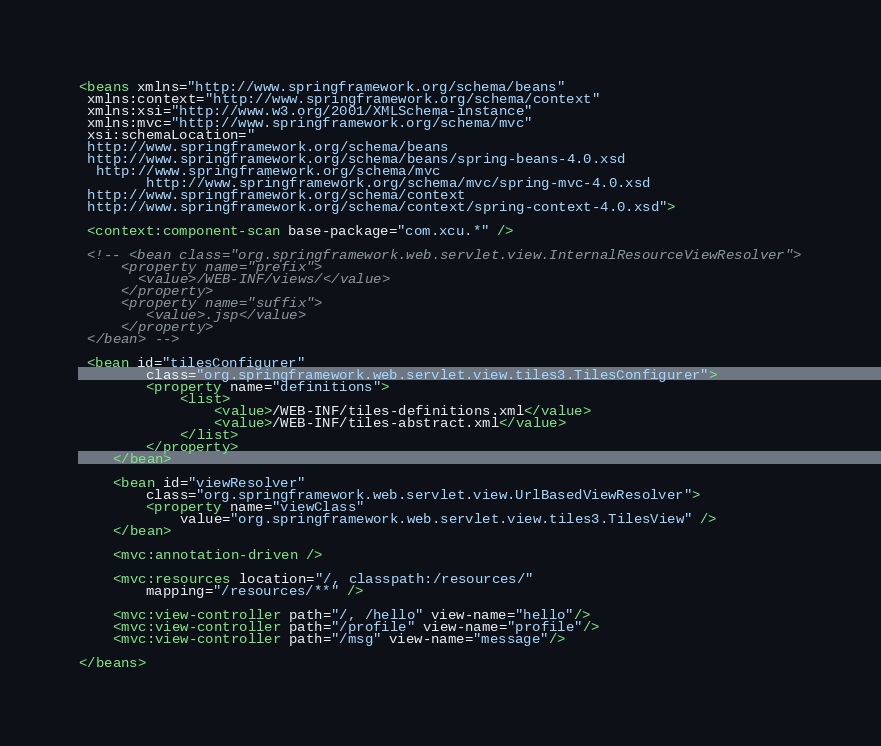Convert code to text. <code><loc_0><loc_0><loc_500><loc_500><_XML_><beans xmlns="http://www.springframework.org/schema/beans"
 xmlns:context="http://www.springframework.org/schema/context"
 xmlns:xsi="http://www.w3.org/2001/XMLSchema-instance"
 xmlns:mvc="http://www.springframework.org/schema/mvc"
 xsi:schemaLocation="
 http://www.springframework.org/schema/beans
 http://www.springframework.org/schema/beans/spring-beans-4.0.xsd
  http://www.springframework.org/schema/mvc 
        http://www.springframework.org/schema/mvc/spring-mvc-4.0.xsd
 http://www.springframework.org/schema/context
 http://www.springframework.org/schema/context/spring-context-4.0.xsd">

 <context:component-scan base-package="com.xcu.*" />

 <!-- <bean class="org.springframework.web.servlet.view.InternalResourceViewResolver">
	 <property name="prefix">
	   <value>/WEB-INF/views/</value>
	 </property>
	 <property name="suffix">
	    <value>.jsp</value>
	 </property>
 </bean> -->
 
 <bean id="tilesConfigurer"
		class="org.springframework.web.servlet.view.tiles3.TilesConfigurer">
		<property name="definitions">
			<list>
				<value>/WEB-INF/tiles-definitions.xml</value>
				<value>/WEB-INF/tiles-abstract.xml</value>
			</list>
		</property>
	</bean>

	<bean id="viewResolver"
		class="org.springframework.web.servlet.view.UrlBasedViewResolver">
		<property name="viewClass"
			value="org.springframework.web.servlet.view.tiles3.TilesView" />
	</bean>
 
 	<mvc:annotation-driven />
 	
	<mvc:resources location="/, classpath:/resources/"
		mapping="/resources/**" />
		
	<mvc:view-controller path="/, /hello" view-name="hello"/>
	<mvc:view-controller path="/profile" view-name="profile"/>
	<mvc:view-controller path="/msg" view-name="message"/>

</beans></code> 